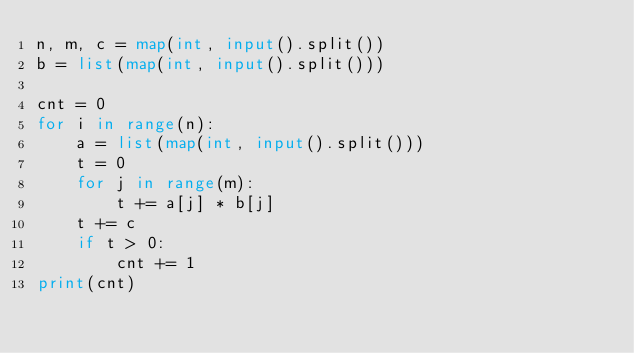Convert code to text. <code><loc_0><loc_0><loc_500><loc_500><_Python_>n, m, c = map(int, input().split())
b = list(map(int, input().split()))

cnt = 0
for i in range(n):
    a = list(map(int, input().split()))
    t = 0
    for j in range(m):
        t += a[j] * b[j]
    t += c
    if t > 0:
        cnt += 1
print(cnt)
</code> 